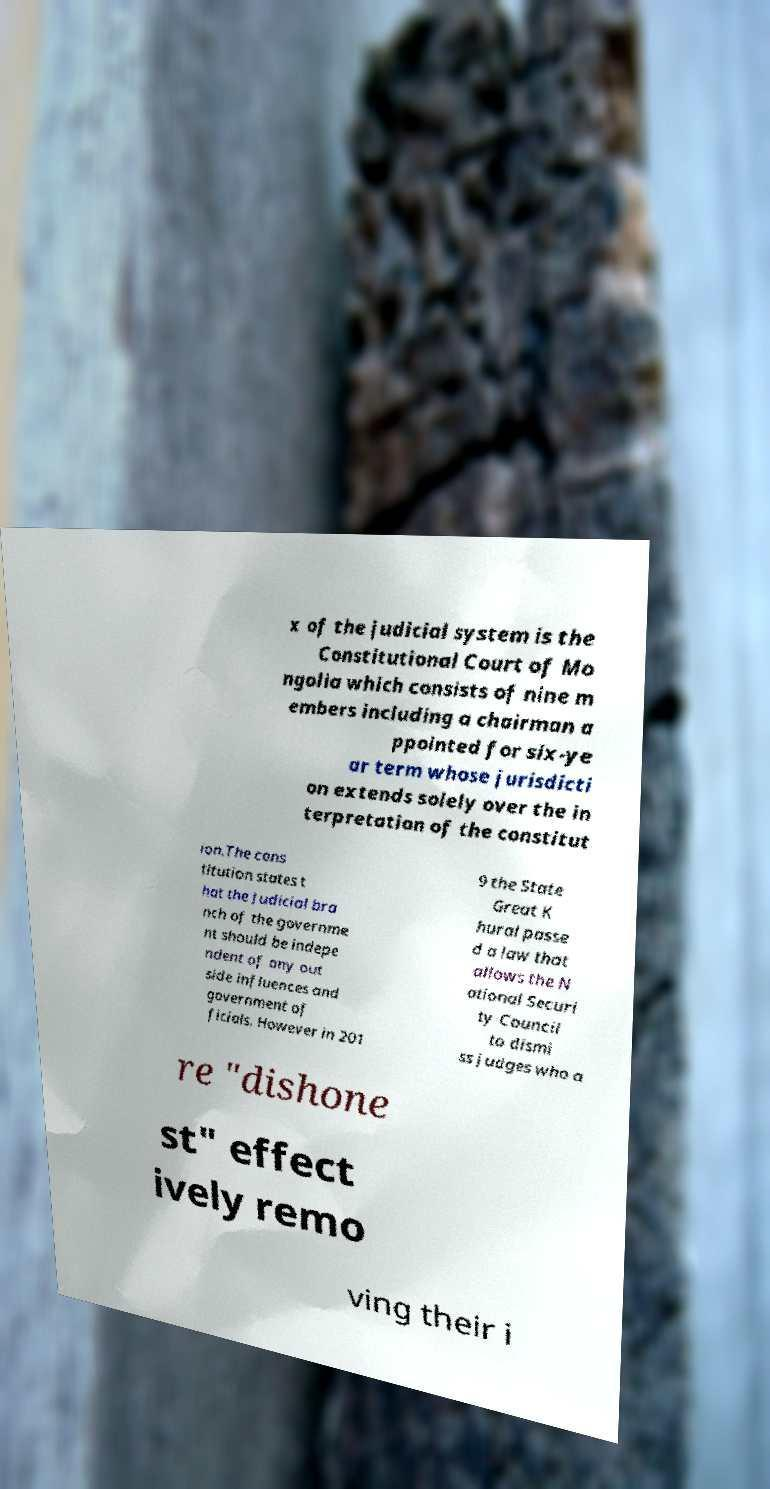Please read and relay the text visible in this image. What does it say? x of the judicial system is the Constitutional Court of Mo ngolia which consists of nine m embers including a chairman a ppointed for six-ye ar term whose jurisdicti on extends solely over the in terpretation of the constitut ion.The cons titution states t hat the Judicial bra nch of the governme nt should be indepe ndent of any out side influences and government of ficials. However in 201 9 the State Great K hural passe d a law that allows the N ational Securi ty Council to dismi ss judges who a re "dishone st" effect ively remo ving their i 